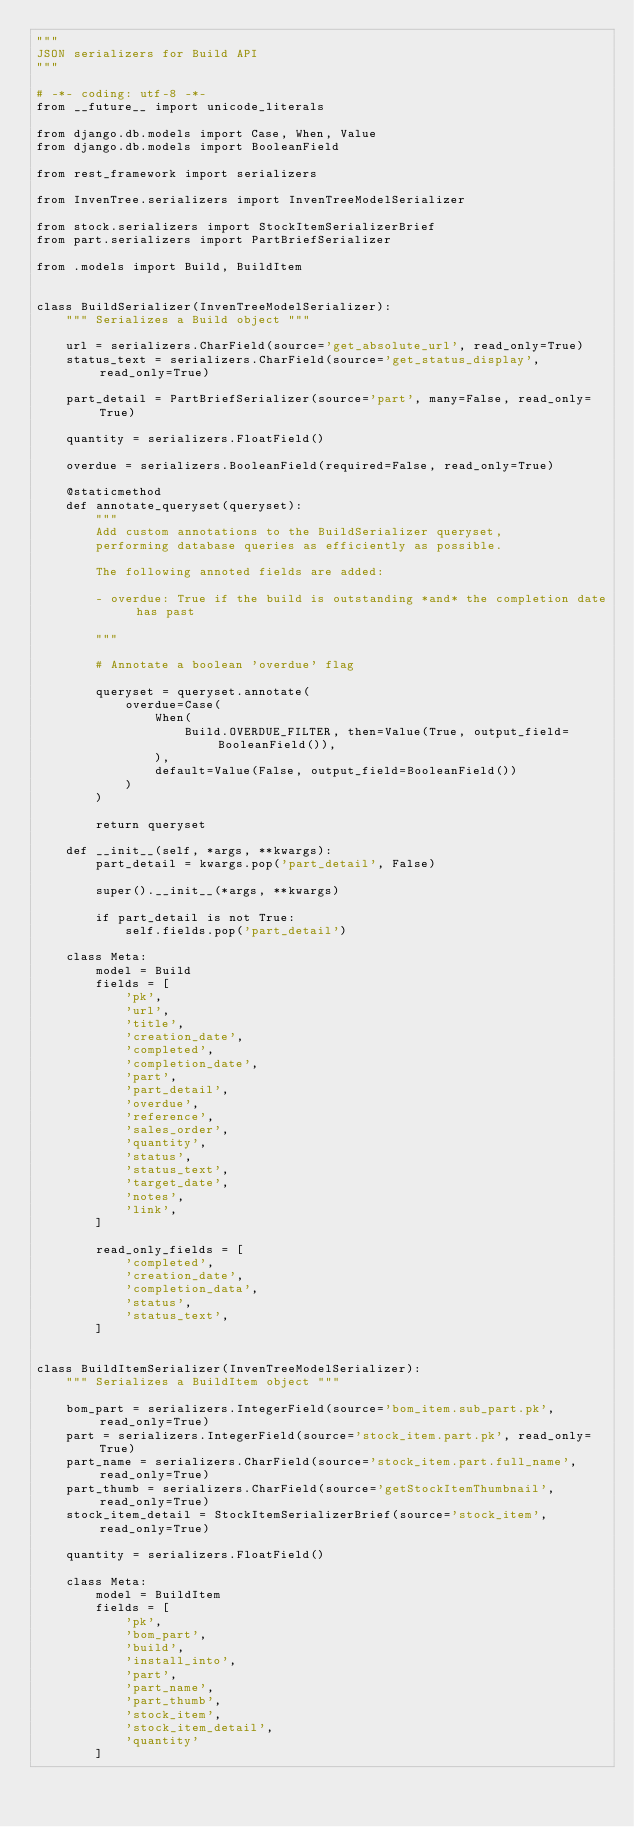<code> <loc_0><loc_0><loc_500><loc_500><_Python_>"""
JSON serializers for Build API
"""

# -*- coding: utf-8 -*-
from __future__ import unicode_literals

from django.db.models import Case, When, Value
from django.db.models import BooleanField

from rest_framework import serializers

from InvenTree.serializers import InvenTreeModelSerializer

from stock.serializers import StockItemSerializerBrief
from part.serializers import PartBriefSerializer

from .models import Build, BuildItem


class BuildSerializer(InvenTreeModelSerializer):
    """ Serializes a Build object """

    url = serializers.CharField(source='get_absolute_url', read_only=True)
    status_text = serializers.CharField(source='get_status_display', read_only=True)

    part_detail = PartBriefSerializer(source='part', many=False, read_only=True)

    quantity = serializers.FloatField()

    overdue = serializers.BooleanField(required=False, read_only=True)

    @staticmethod
    def annotate_queryset(queryset):
        """
        Add custom annotations to the BuildSerializer queryset,
        performing database queries as efficiently as possible.

        The following annoted fields are added:

        - overdue: True if the build is outstanding *and* the completion date has past

        """

        # Annotate a boolean 'overdue' flag

        queryset = queryset.annotate(
            overdue=Case(
                When(
                    Build.OVERDUE_FILTER, then=Value(True, output_field=BooleanField()),
                ),
                default=Value(False, output_field=BooleanField())
            )
        )

        return queryset

    def __init__(self, *args, **kwargs):
        part_detail = kwargs.pop('part_detail', False)

        super().__init__(*args, **kwargs)

        if part_detail is not True:
            self.fields.pop('part_detail')

    class Meta:
        model = Build
        fields = [
            'pk',
            'url',
            'title',
            'creation_date',
            'completed',
            'completion_date',
            'part',
            'part_detail',
            'overdue',
            'reference',
            'sales_order',
            'quantity',
            'status',
            'status_text',
            'target_date',
            'notes',
            'link',
        ]

        read_only_fields = [
            'completed',
            'creation_date',
            'completion_data',
            'status',
            'status_text',
        ]


class BuildItemSerializer(InvenTreeModelSerializer):
    """ Serializes a BuildItem object """

    bom_part = serializers.IntegerField(source='bom_item.sub_part.pk', read_only=True)
    part = serializers.IntegerField(source='stock_item.part.pk', read_only=True)
    part_name = serializers.CharField(source='stock_item.part.full_name', read_only=True)
    part_thumb = serializers.CharField(source='getStockItemThumbnail', read_only=True)
    stock_item_detail = StockItemSerializerBrief(source='stock_item', read_only=True)

    quantity = serializers.FloatField()

    class Meta:
        model = BuildItem
        fields = [
            'pk',
            'bom_part',
            'build',
            'install_into',
            'part',
            'part_name',
            'part_thumb',
            'stock_item',
            'stock_item_detail',
            'quantity'
        ]
</code> 